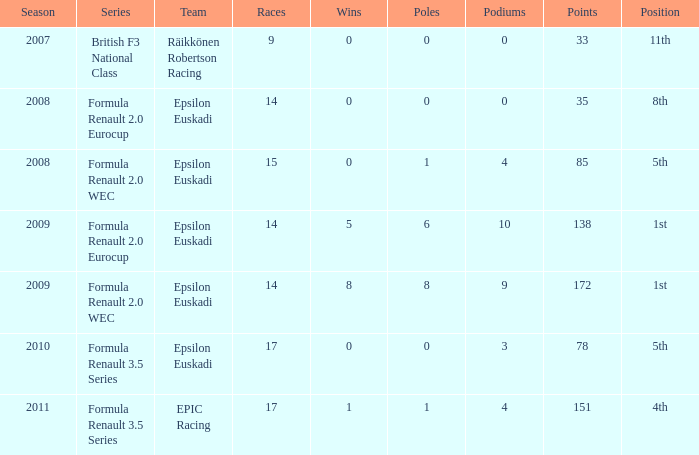How many f/laps when he finished 8th? 1.0. 